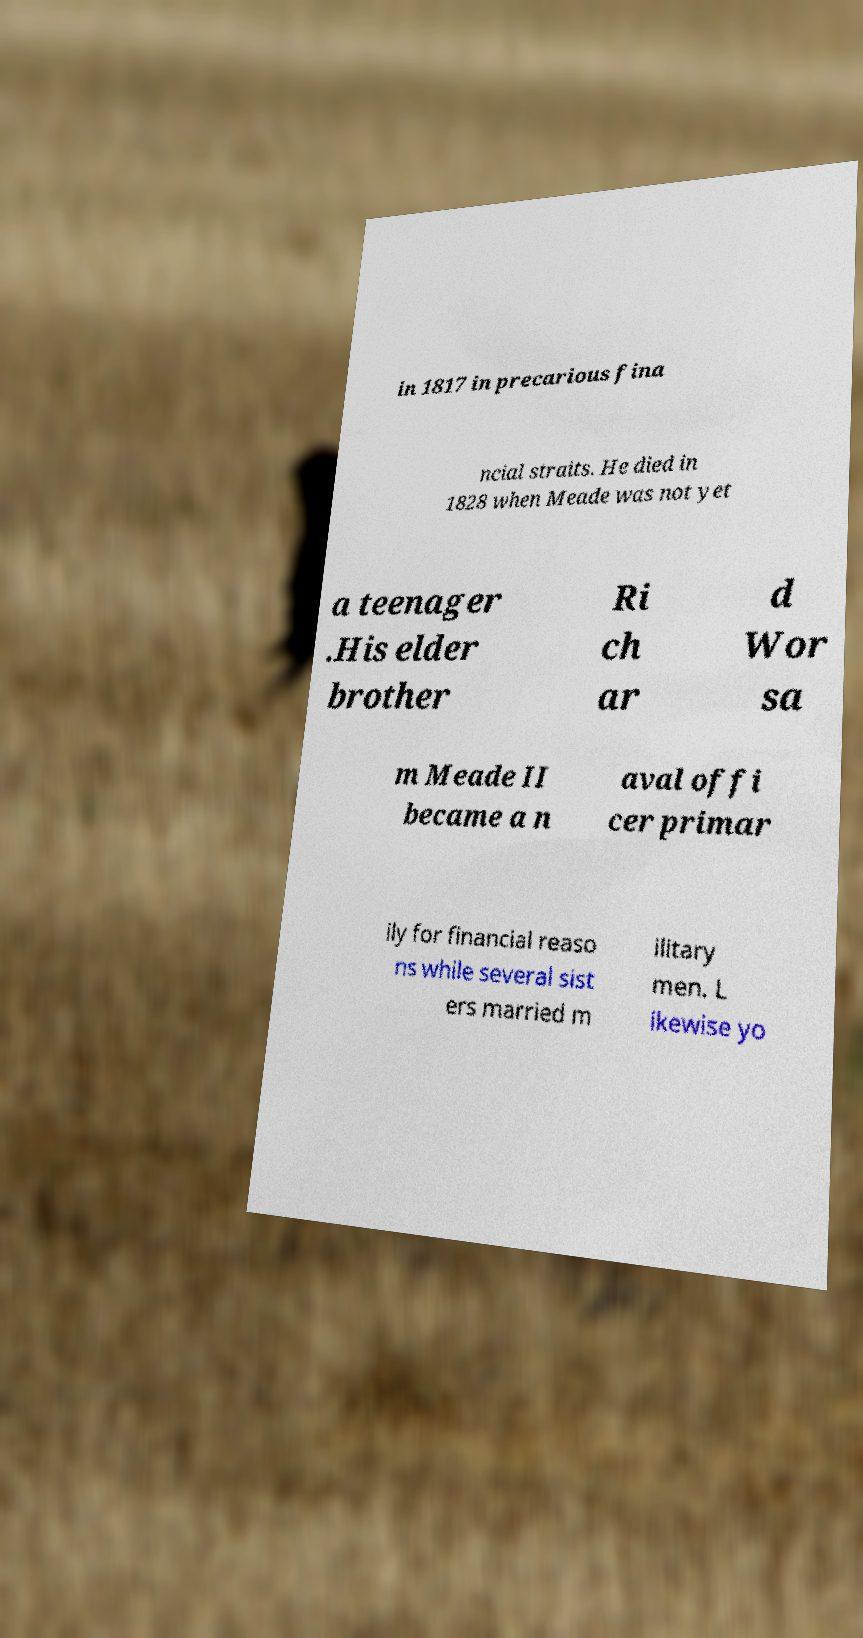There's text embedded in this image that I need extracted. Can you transcribe it verbatim? in 1817 in precarious fina ncial straits. He died in 1828 when Meade was not yet a teenager .His elder brother Ri ch ar d Wor sa m Meade II became a n aval offi cer primar ily for financial reaso ns while several sist ers married m ilitary men. L ikewise yo 